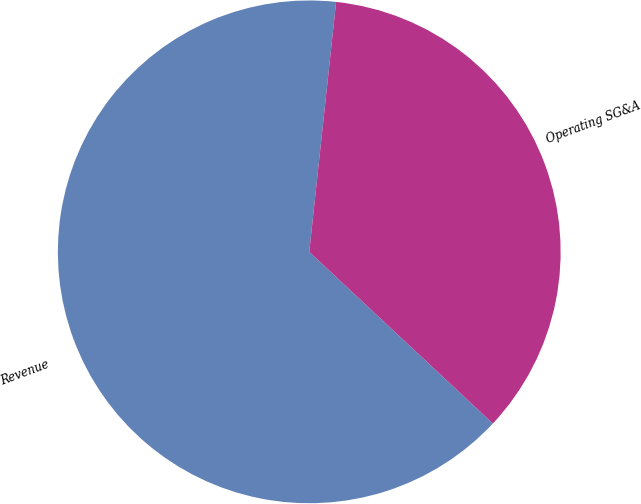Convert chart. <chart><loc_0><loc_0><loc_500><loc_500><pie_chart><fcel>Revenue<fcel>Operating SG&A<nl><fcel>64.74%<fcel>35.26%<nl></chart> 